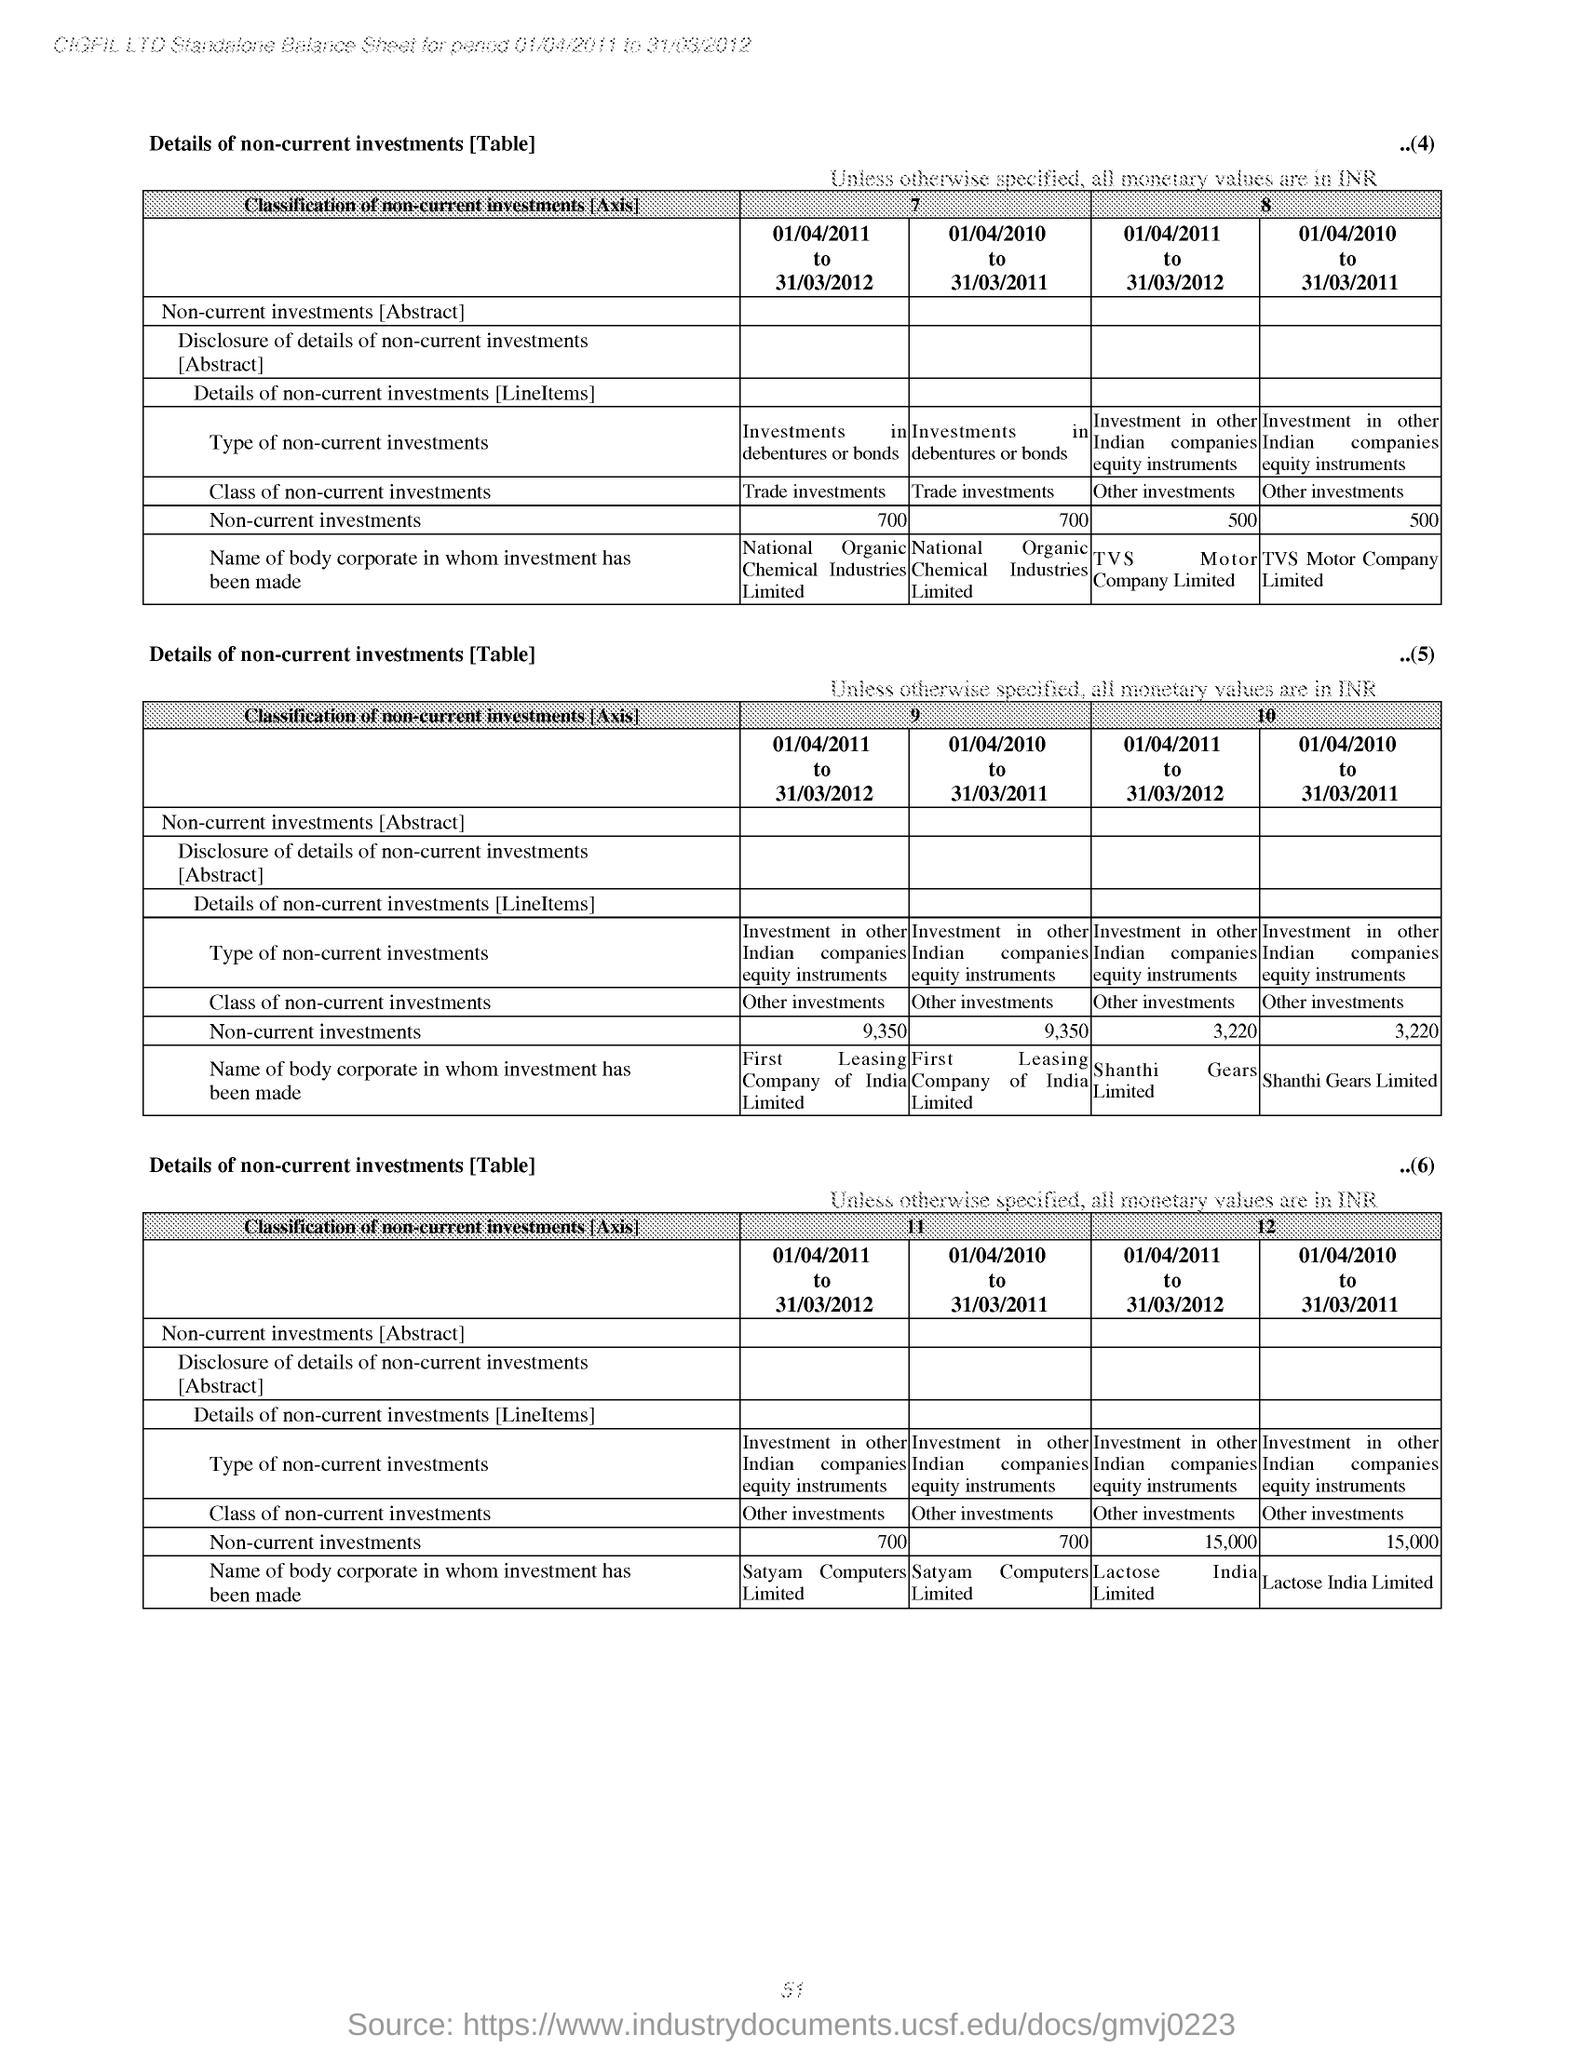Specify some key components in this picture. The non-current investments for the period 01/04/2011 to 31/03/2012 are listed under the column "7" of the first table, with a value of 700. National Organic Chemical Industries Limited is the body corporate in which investment was made for the period of April 1, 2011 to March 31, 2012 under column '7' of table 1. 